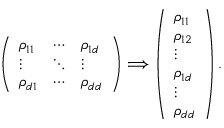<formula> <loc_0><loc_0><loc_500><loc_500>\left ( \begin{array} { l l l } { \rho _ { 1 1 } } & { \cdots } & { \rho _ { 1 d } } \\ { \vdots } & { \ddots } & { \vdots } \\ { \rho _ { d 1 } } & { \cdots } & { \rho _ { d d } } \end{array} \right ) \Longrightarrow \left ( \begin{array} { l } { \rho _ { 1 1 } } \\ { \rho _ { 1 2 } } \\ { \vdots } \\ { \rho _ { 1 d } } \\ { \vdots } \\ { \rho _ { d d } } \end{array} \right ) .</formula> 